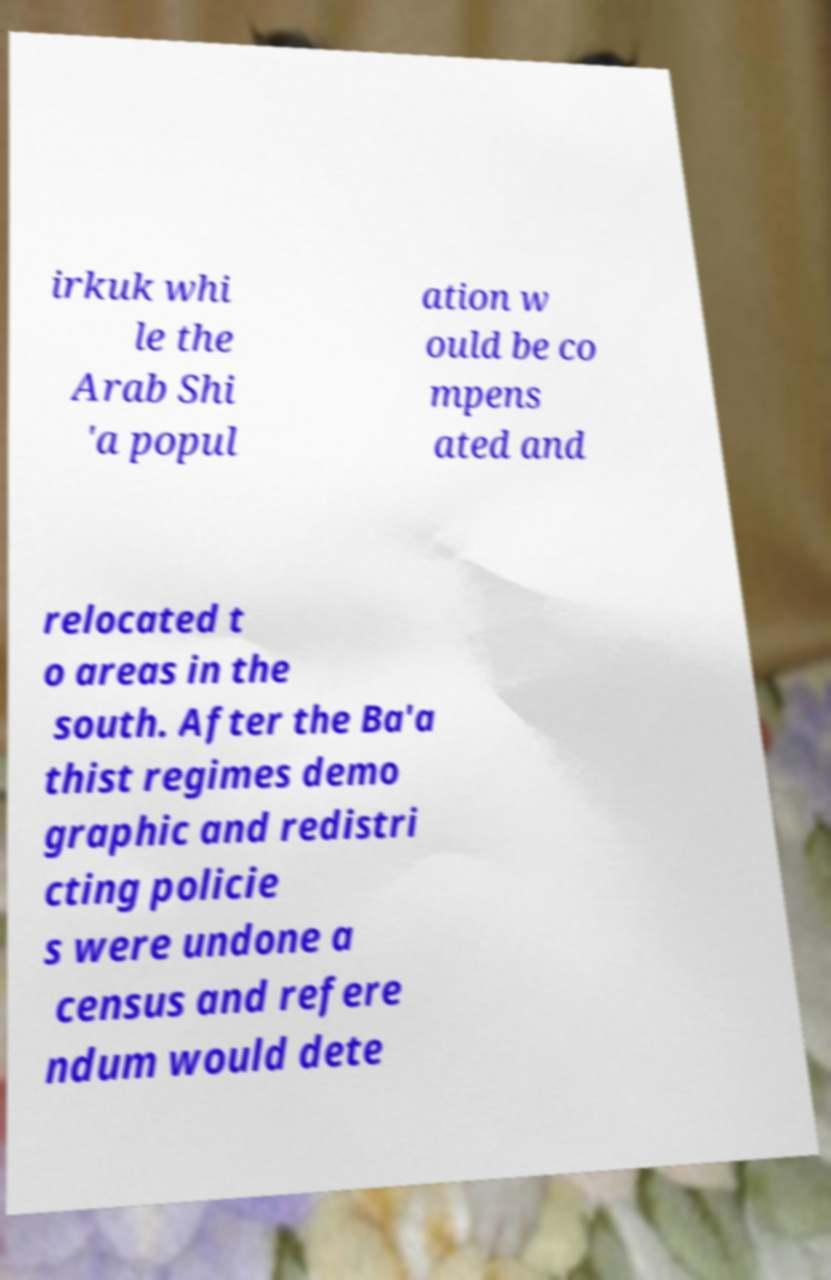There's text embedded in this image that I need extracted. Can you transcribe it verbatim? irkuk whi le the Arab Shi 'a popul ation w ould be co mpens ated and relocated t o areas in the south. After the Ba'a thist regimes demo graphic and redistri cting policie s were undone a census and refere ndum would dete 